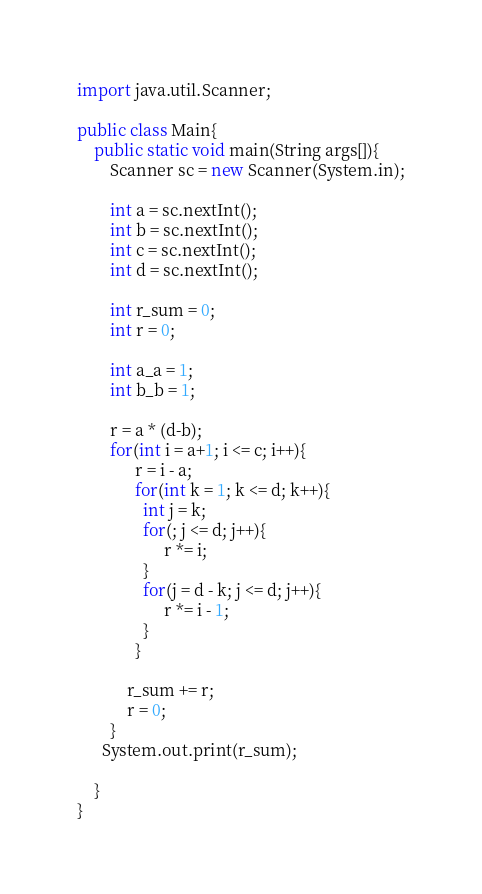<code> <loc_0><loc_0><loc_500><loc_500><_Java_>import java.util.Scanner;

public class Main{
	public static void main(String args[]){
    	Scanner sc = new Scanner(System.in);
      
      	int a = sc.nextInt();
      	int b = sc.nextInt();
      	int c = sc.nextInt();
      	int d = sc.nextInt();
      
      	int r_sum = 0;
      	int r = 0;
      
      	int a_a = 1;
        int b_b = 1;
      
      	r = a * (d-b);
      	for(int i = a+1; i <= c; i++){
              r = i - a;
              for(int k = 1; k <= d; k++){
                int j = k;
                for(; j <= d; j++){
                     r *= i; 
                }
                for(j = d - k; j <= d; j++){
                     r *= i - 1; 
                }
              }
          
          	r_sum += r;
	        r = 0;
        }
      System.out.print(r_sum);
      	
    }
}
</code> 